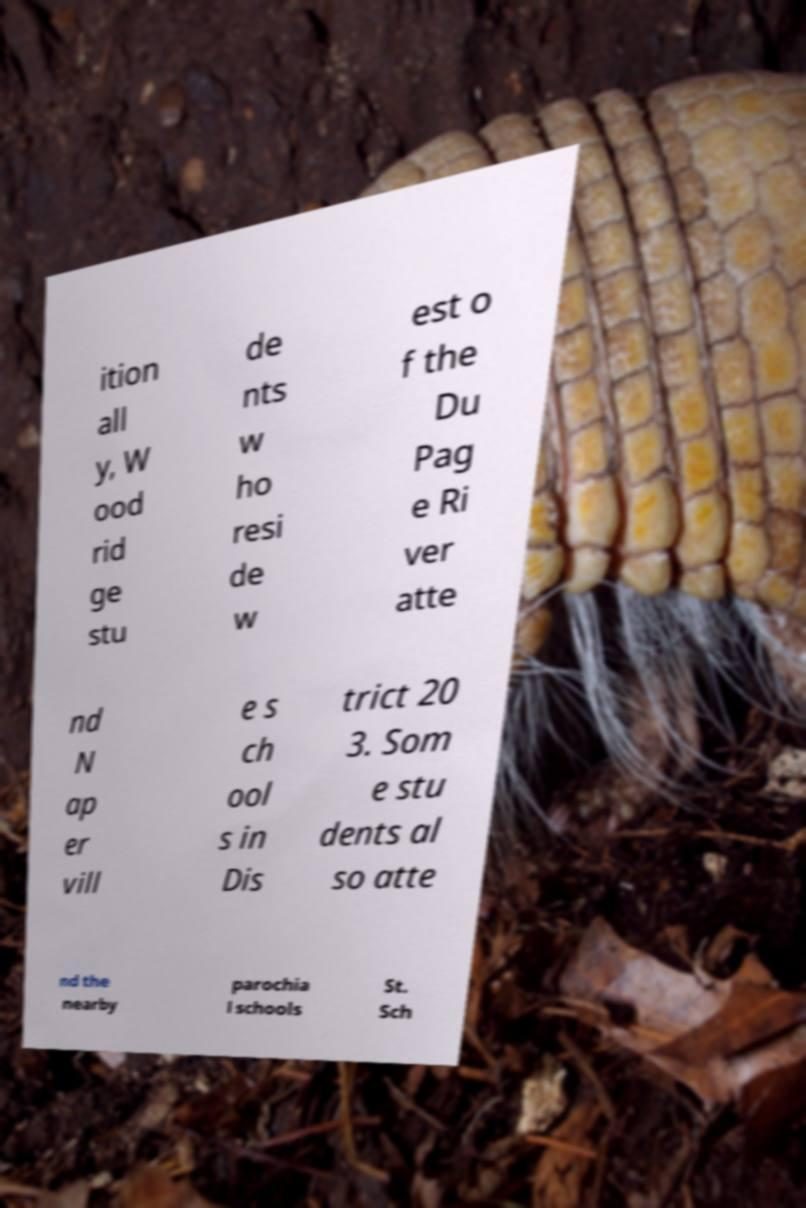For documentation purposes, I need the text within this image transcribed. Could you provide that? ition all y, W ood rid ge stu de nts w ho resi de w est o f the Du Pag e Ri ver atte nd N ap er vill e s ch ool s in Dis trict 20 3. Som e stu dents al so atte nd the nearby parochia l schools St. Sch 